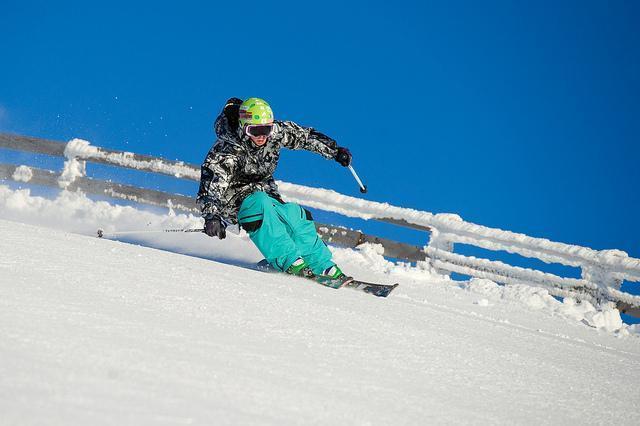How many facets does this sink have?
Give a very brief answer. 0. 